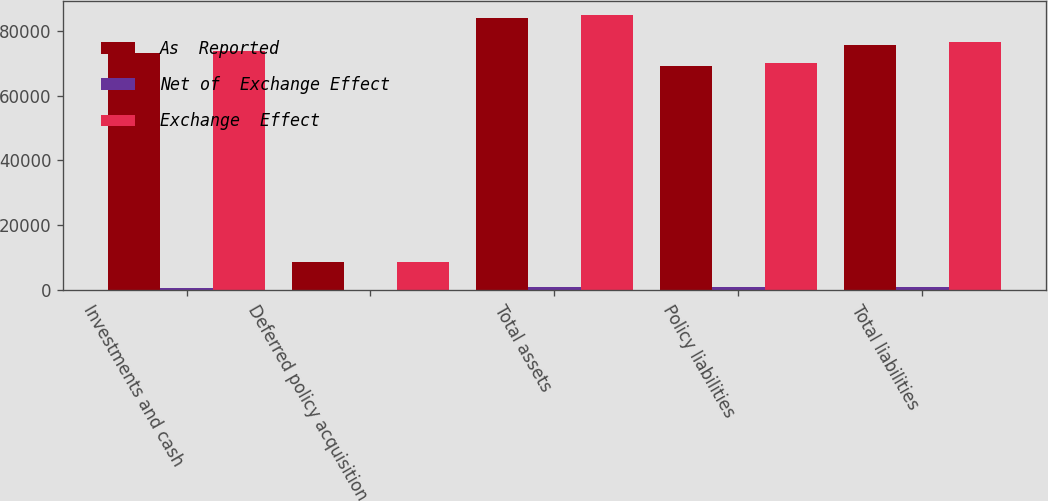Convert chart. <chart><loc_0><loc_0><loc_500><loc_500><stacked_bar_chart><ecel><fcel>Investments and cash<fcel>Deferred policy acquisition<fcel>Total assets<fcel>Policy liabilities<fcel>Total liabilities<nl><fcel>As  Reported<fcel>73192<fcel>8533<fcel>84106<fcel>69245<fcel>75689<nl><fcel>Net of  Exchange Effect<fcel>714<fcel>69<fcel>799<fcel>729<fcel>778<nl><fcel>Exchange  Effect<fcel>73906<fcel>8602<fcel>84905<fcel>69974<fcel>76467<nl></chart> 